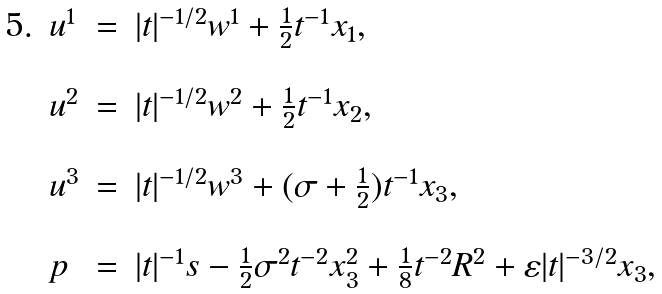<formula> <loc_0><loc_0><loc_500><loc_500>\, \begin{array} { l l l l } 5 . & u ^ { 1 } & = & | t | ^ { - 1 / 2 } w ^ { 1 } + \frac { 1 } { 2 } t ^ { - 1 } x _ { 1 } , \\ \\ & u ^ { 2 } & = & | t | ^ { - 1 / 2 } w ^ { 2 } + \frac { 1 } { 2 } t ^ { - 1 } x _ { 2 } , \\ \\ & u ^ { 3 } & = & | t | ^ { - 1 / 2 } w ^ { 3 } + ( \sigma + \frac { 1 } { 2 } ) t ^ { - 1 } x _ { 3 } , \\ \\ & p & = & | t | ^ { - 1 } s - \frac { 1 } { 2 } \sigma ^ { 2 } t ^ { - 2 } x ^ { 2 } _ { 3 } + \frac { 1 } { 8 } t ^ { - 2 } R ^ { 2 } + \varepsilon | t | ^ { - 3 / 2 } x _ { 3 } , \end{array}</formula> 